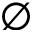<formula> <loc_0><loc_0><loc_500><loc_500>\emptyset</formula> 